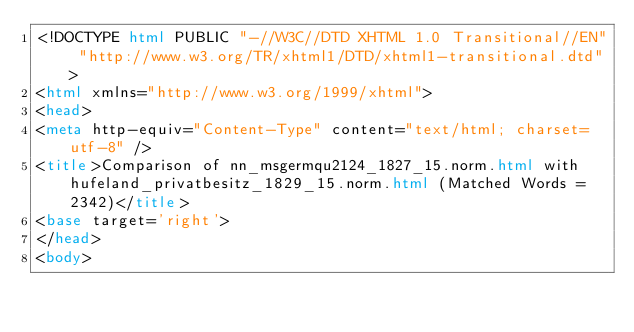Convert code to text. <code><loc_0><loc_0><loc_500><loc_500><_HTML_><!DOCTYPE html PUBLIC "-//W3C//DTD XHTML 1.0 Transitional//EN" "http://www.w3.org/TR/xhtml1/DTD/xhtml1-transitional.dtd">
<html xmlns="http://www.w3.org/1999/xhtml">
<head>
<meta http-equiv="Content-Type" content="text/html; charset=utf-8" />
<title>Comparison of nn_msgermqu2124_1827_15.norm.html with hufeland_privatbesitz_1829_15.norm.html (Matched Words = 2342)</title>
<base target='right'>
</head>
<body></code> 